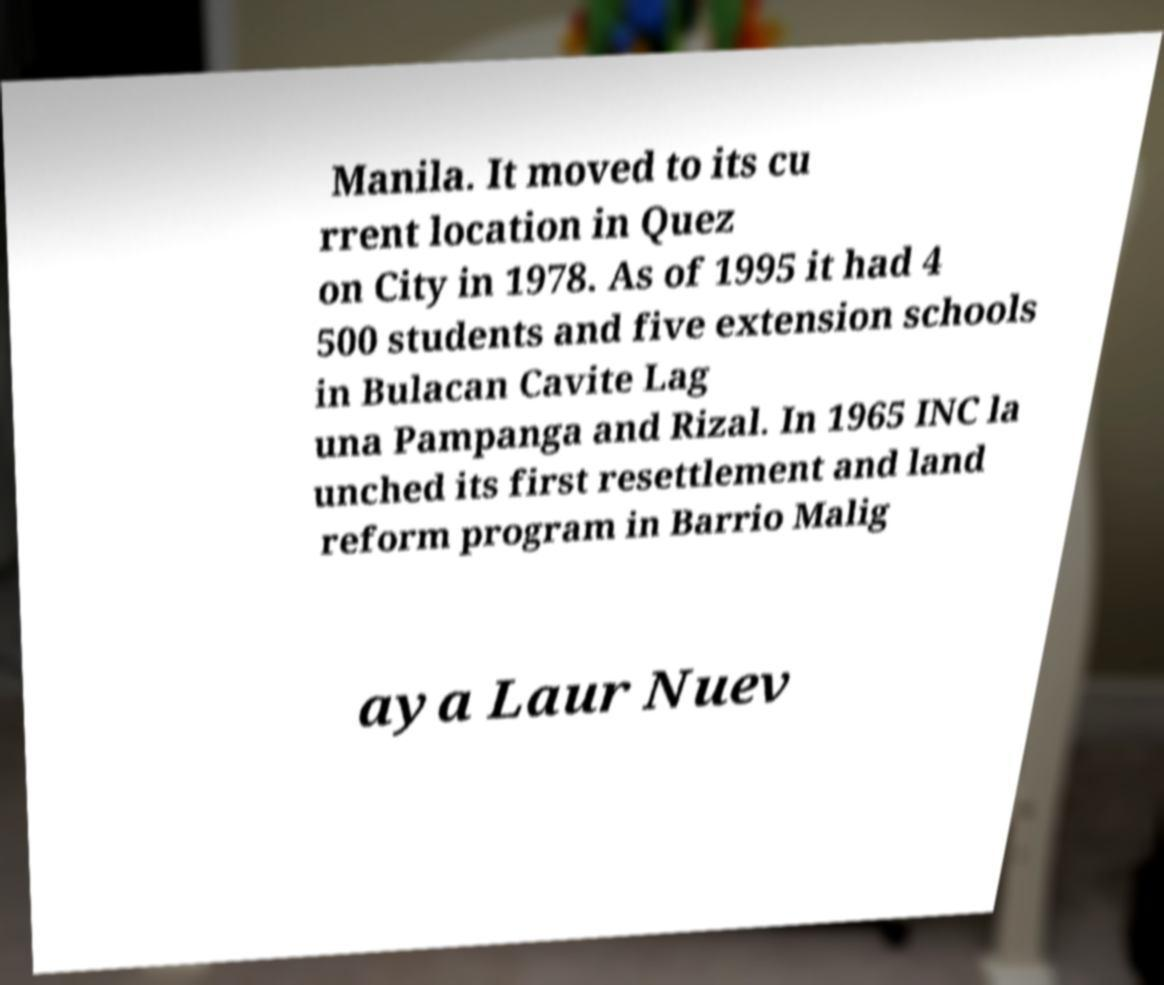Could you extract and type out the text from this image? Manila. It moved to its cu rrent location in Quez on City in 1978. As of 1995 it had 4 500 students and five extension schools in Bulacan Cavite Lag una Pampanga and Rizal. In 1965 INC la unched its first resettlement and land reform program in Barrio Malig aya Laur Nuev 